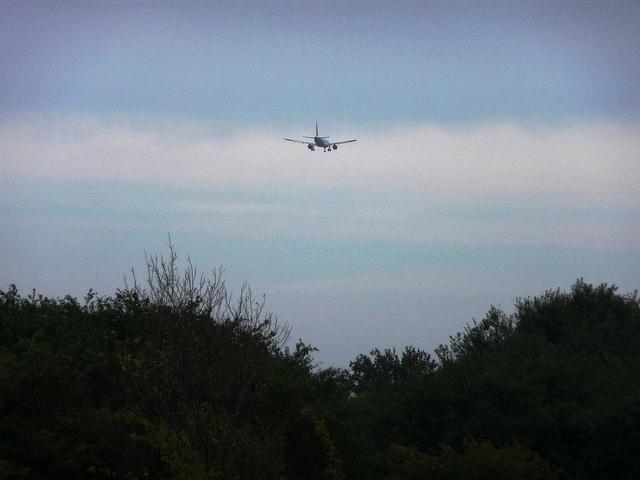How many planes are flying in formation?
Be succinct. 1. Are there any people?
Be succinct. No. Does the trees have leaves?
Concise answer only. Yes. If the plane is flying east, will it see the sun rise?
Answer briefly. Yes. What is in the sky?
Answer briefly. Plane. What is the flying object?
Answer briefly. Plane. What type of vehicle are these people operating?
Quick response, please. Plane. Do the trees cover the entire ground?
Short answer required. Yes. Is it raining in this picture?
Quick response, please. No. Are there any buildings in the background?
Write a very short answer. No. Is the person going down or up?
Short answer required. Down. Is it a drone or a kite in the sky?
Concise answer only. Neither. What is flying in the air?
Be succinct. Airplane. Is this airplane close to an airport?
Answer briefly. Yes. What is in the air?
Write a very short answer. Airplane. Are there bikes  shown?
Give a very brief answer. No. Are there trees in the photo?
Quick response, please. Yes. Does the weather appear to be windy?
Short answer required. No. 